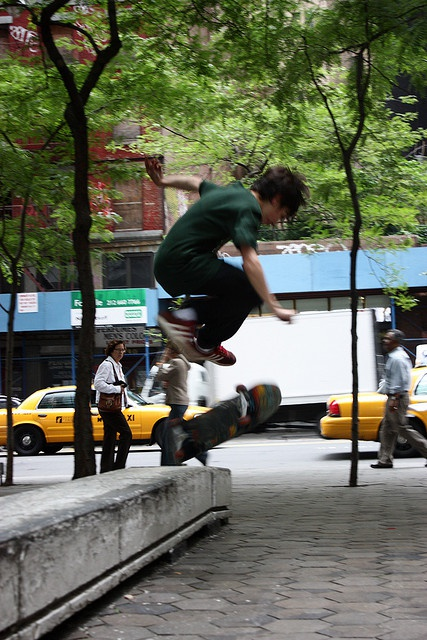Describe the objects in this image and their specific colors. I can see people in darkgreen, black, gray, maroon, and teal tones, truck in darkgreen, white, black, darkgray, and gray tones, car in darkgreen, black, orange, ivory, and olive tones, skateboard in darkgreen, black, gray, maroon, and darkgray tones, and car in darkgreen, white, black, olive, and orange tones in this image. 